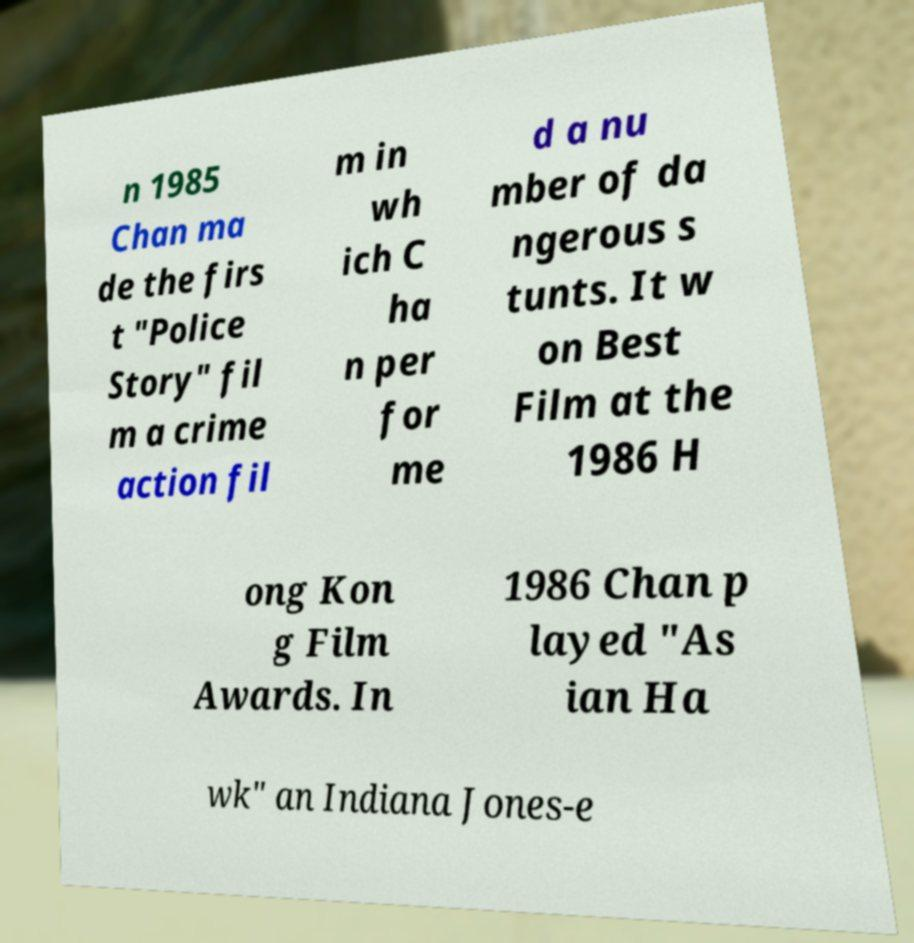For documentation purposes, I need the text within this image transcribed. Could you provide that? n 1985 Chan ma de the firs t "Police Story" fil m a crime action fil m in wh ich C ha n per for me d a nu mber of da ngerous s tunts. It w on Best Film at the 1986 H ong Kon g Film Awards. In 1986 Chan p layed "As ian Ha wk" an Indiana Jones-e 